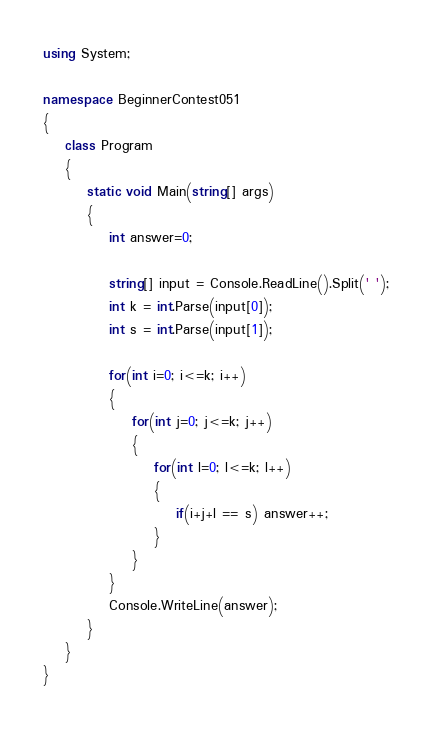Convert code to text. <code><loc_0><loc_0><loc_500><loc_500><_C#_>using System;

namespace BeginnerContest051
{
    class Program
    {
        static void Main(string[] args)
        {
            int answer=0;

            string[] input = Console.ReadLine().Split(' ');
            int k = int.Parse(input[0]);
            int s = int.Parse(input[1]);

            for(int i=0; i<=k; i++)
            {
                for(int j=0; j<=k; j++)
                {
                    for(int l=0; l<=k; l++)
                    {
                        if(i+j+l == s) answer++;
                    }   
                }
            }
            Console.WriteLine(answer);
        }
    }
}
</code> 